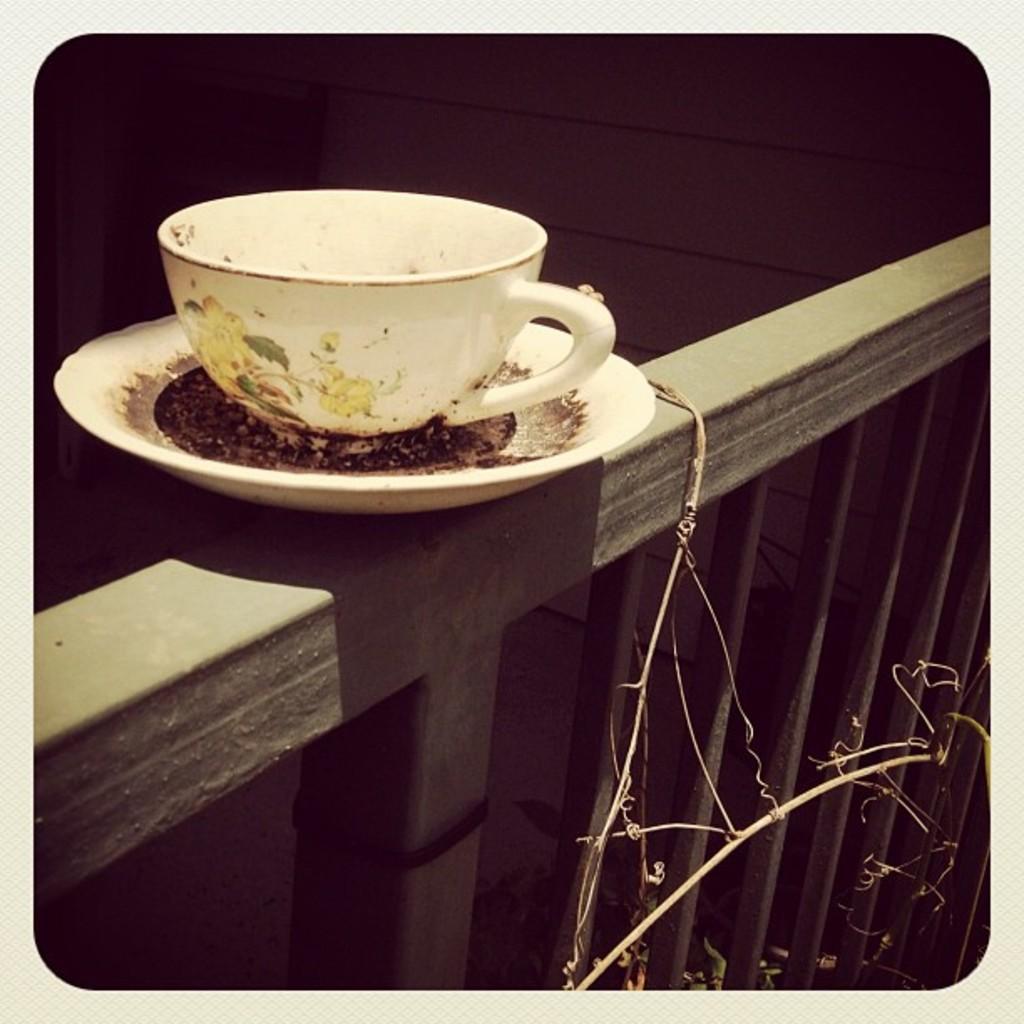In one or two sentences, can you explain what this image depicts? In the image we can see saucer and the cup. Here we can see the fence and the wall. 